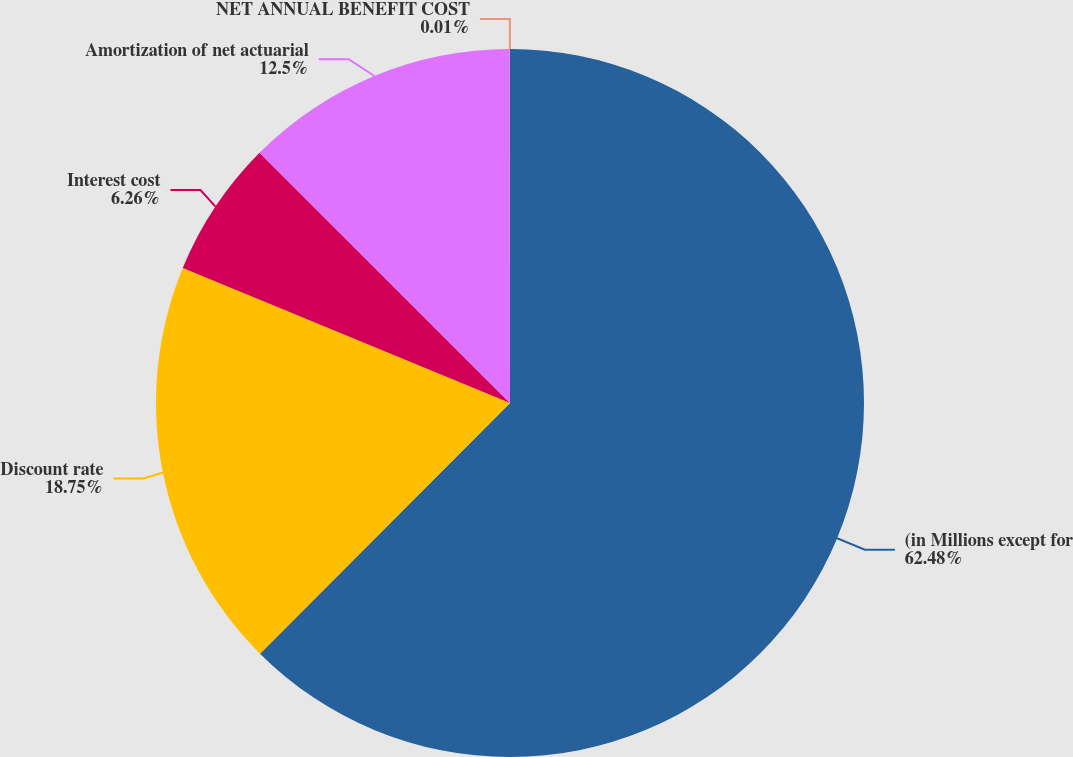<chart> <loc_0><loc_0><loc_500><loc_500><pie_chart><fcel>(in Millions except for<fcel>Discount rate<fcel>Interest cost<fcel>Amortization of net actuarial<fcel>NET ANNUAL BENEFIT COST<nl><fcel>62.48%<fcel>18.75%<fcel>6.26%<fcel>12.5%<fcel>0.01%<nl></chart> 